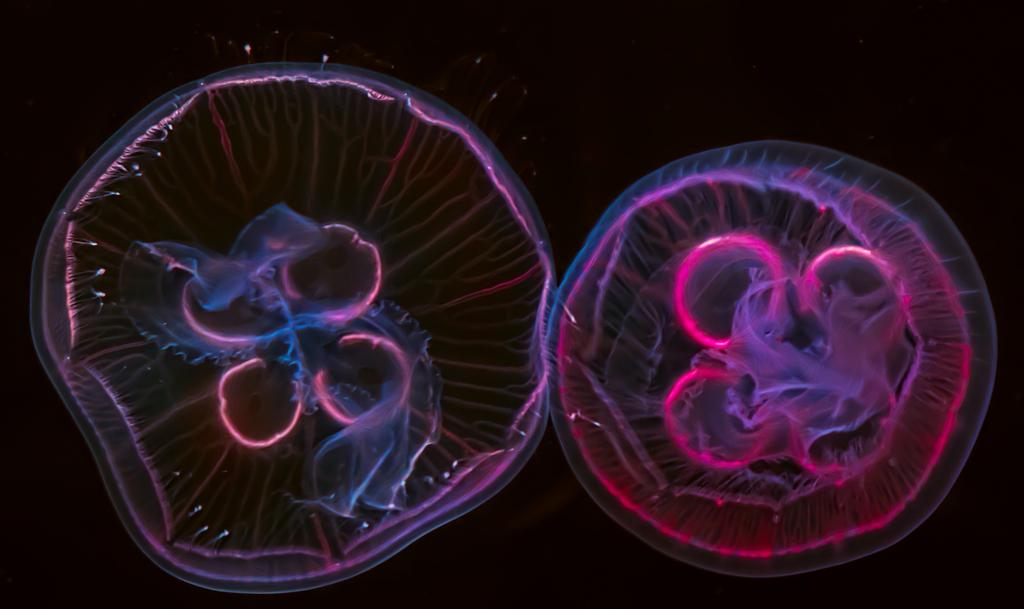What creatures are present in the image? There are two jellyfish in the image. What can be observed about the background of the image? The background of the image appears dark. What time of day is the governor ringing the bell in the image? There is no governor or bell present in the image; it features two jellyfish against a dark background. 